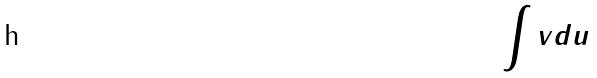Convert formula to latex. <formula><loc_0><loc_0><loc_500><loc_500>\int v d u</formula> 